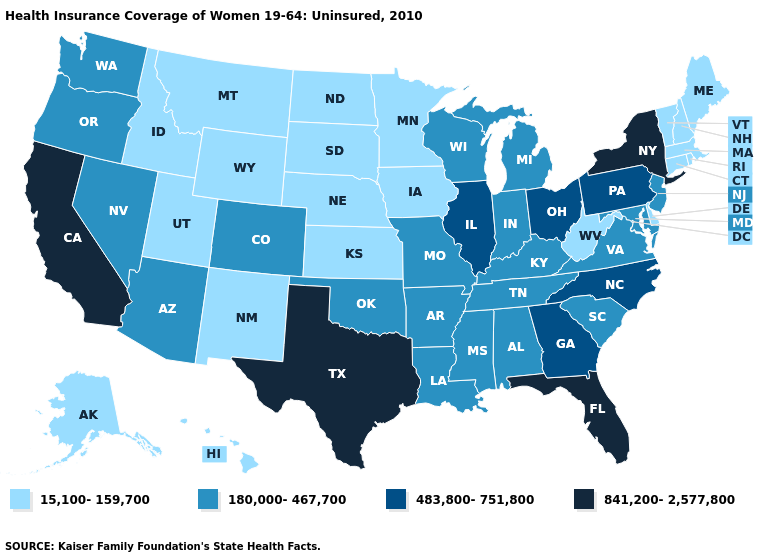Among the states that border Pennsylvania , does Delaware have the highest value?
Answer briefly. No. Name the states that have a value in the range 841,200-2,577,800?
Keep it brief. California, Florida, New York, Texas. What is the value of Maryland?
Answer briefly. 180,000-467,700. Does Delaware have the highest value in the USA?
Keep it brief. No. What is the value of South Dakota?
Short answer required. 15,100-159,700. Among the states that border New Mexico , which have the lowest value?
Answer briefly. Utah. Among the states that border New York , which have the highest value?
Answer briefly. Pennsylvania. Does Virginia have the highest value in the USA?
Short answer required. No. What is the highest value in the West ?
Keep it brief. 841,200-2,577,800. What is the value of Nebraska?
Give a very brief answer. 15,100-159,700. What is the value of Utah?
Quick response, please. 15,100-159,700. Which states have the lowest value in the West?
Concise answer only. Alaska, Hawaii, Idaho, Montana, New Mexico, Utah, Wyoming. Name the states that have a value in the range 483,800-751,800?
Write a very short answer. Georgia, Illinois, North Carolina, Ohio, Pennsylvania. What is the lowest value in the South?
Concise answer only. 15,100-159,700. 